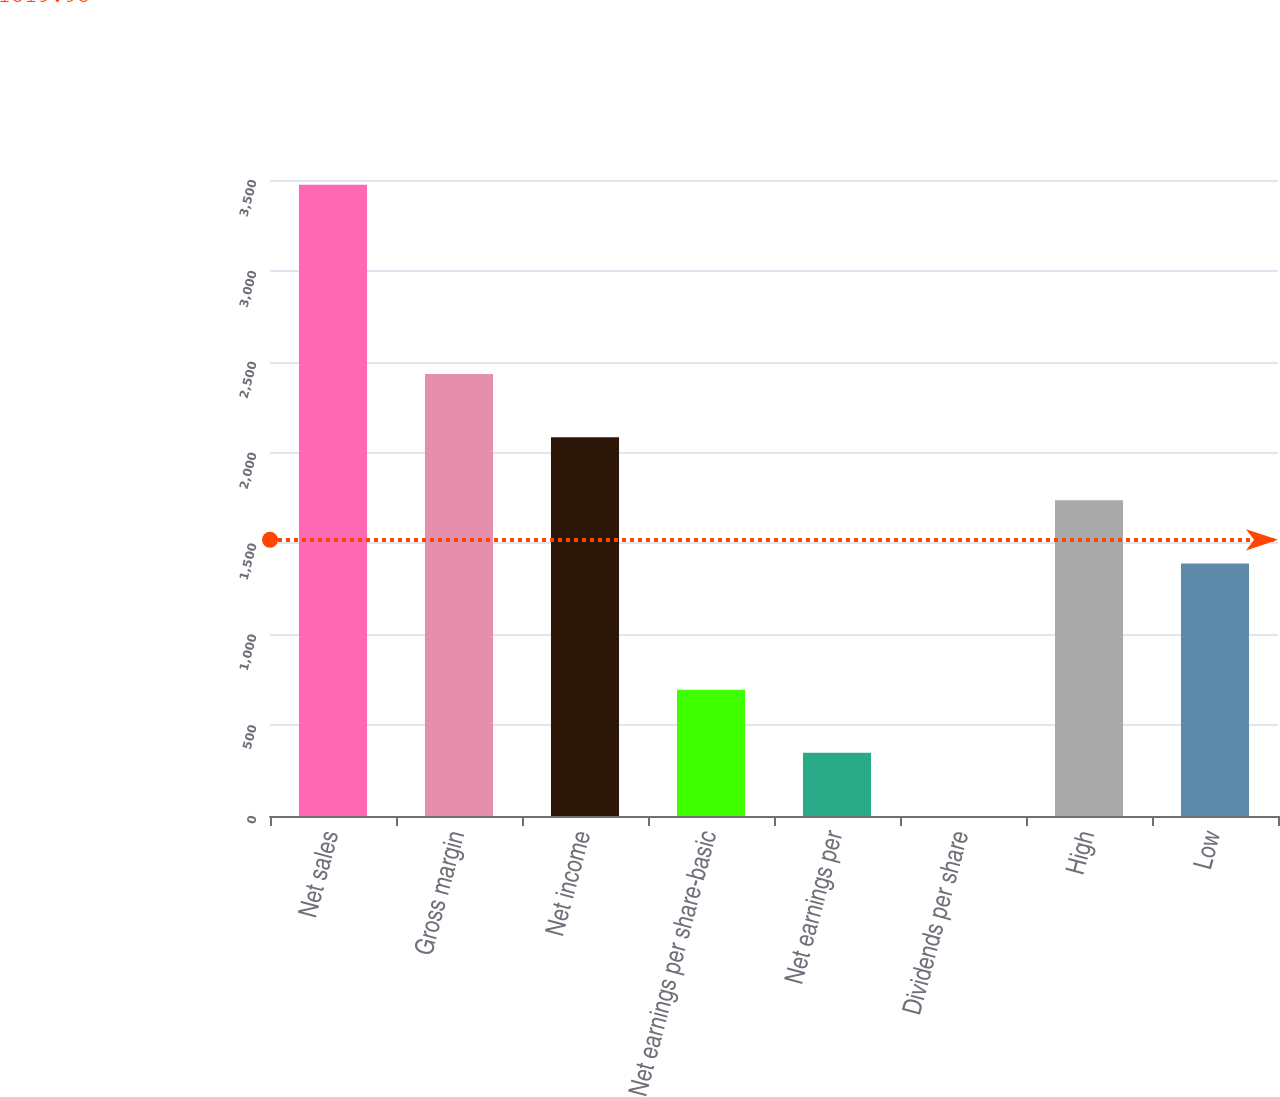Convert chart to OTSL. <chart><loc_0><loc_0><loc_500><loc_500><bar_chart><fcel>Net sales<fcel>Gross margin<fcel>Net income<fcel>Net earnings per share-basic<fcel>Net earnings per<fcel>Dividends per share<fcel>High<fcel>Low<nl><fcel>3474<fcel>2431.85<fcel>2084.46<fcel>694.9<fcel>347.51<fcel>0.12<fcel>1737.07<fcel>1389.68<nl></chart> 